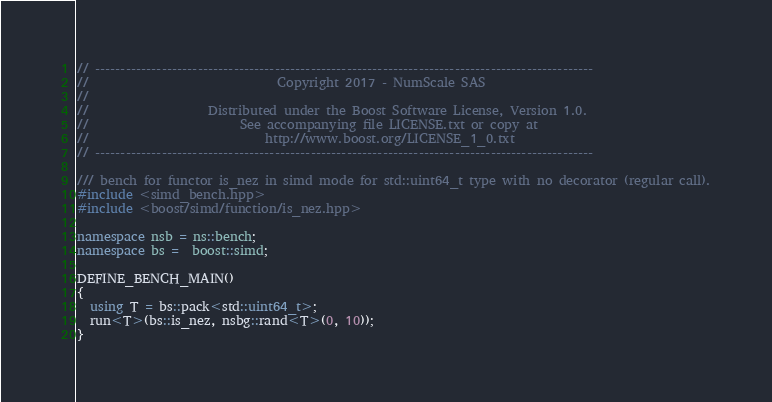<code> <loc_0><loc_0><loc_500><loc_500><_C++_>// -------------------------------------------------------------------------------------------------
//                              Copyright 2017 - NumScale SAS
//
//                   Distributed under the Boost Software License, Version 1.0.
//                        See accompanying file LICENSE.txt or copy at
//                            http://www.boost.org/LICENSE_1_0.txt
// -------------------------------------------------------------------------------------------------

/// bench for functor is_nez in simd mode for std::uint64_t type with no decorator (regular call).
#include <simd_bench.hpp>
#include <boost/simd/function/is_nez.hpp>

namespace nsb = ns::bench;
namespace bs =  boost::simd;

DEFINE_BENCH_MAIN()
{
  using T = bs::pack<std::uint64_t>;
  run<T>(bs::is_nez, nsbg::rand<T>(0, 10));
}

</code> 